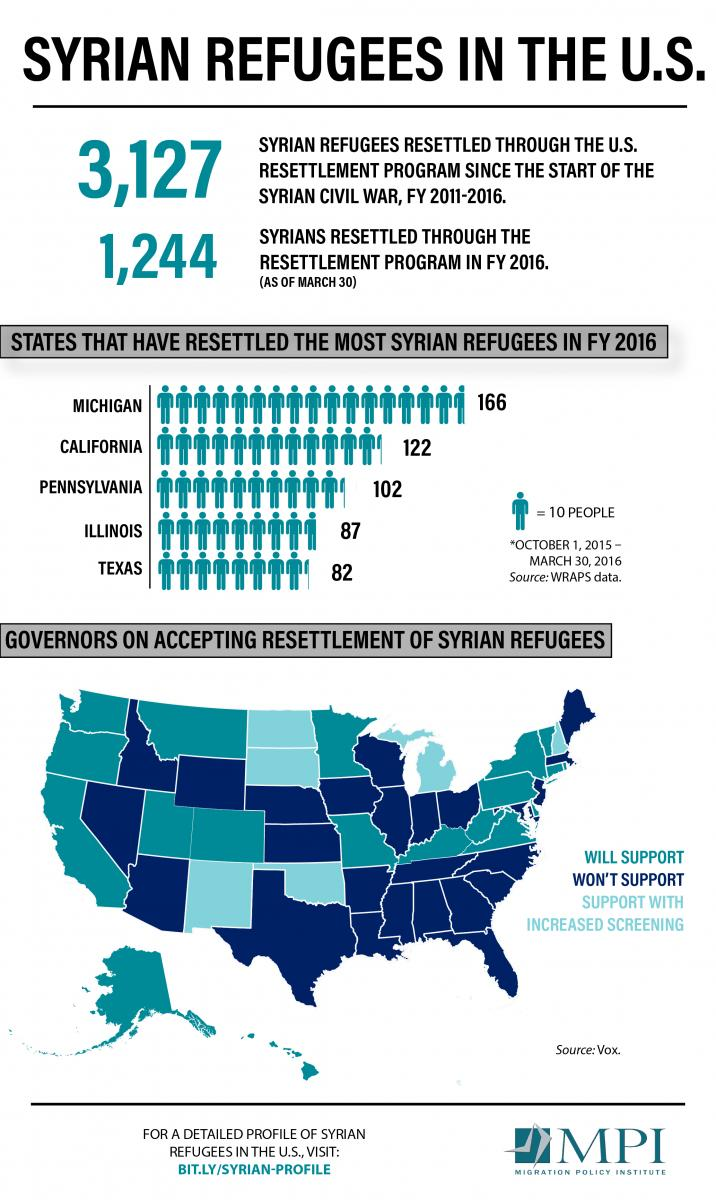Specify some key components in this picture. California is the state with the second highest number of Syrian refugees. It is estimated that two islands will be capable of supporting the resettlement of Syrian refugees. It is reported that seven states have implemented increased screening measures to support the resettlement of Syrian refugees. Out of 50 states in the USA, 25 states have not committed to supporting the resettlement of Syrian refugees. The state with the second lowest number of Syrian refugees is Illinois. 